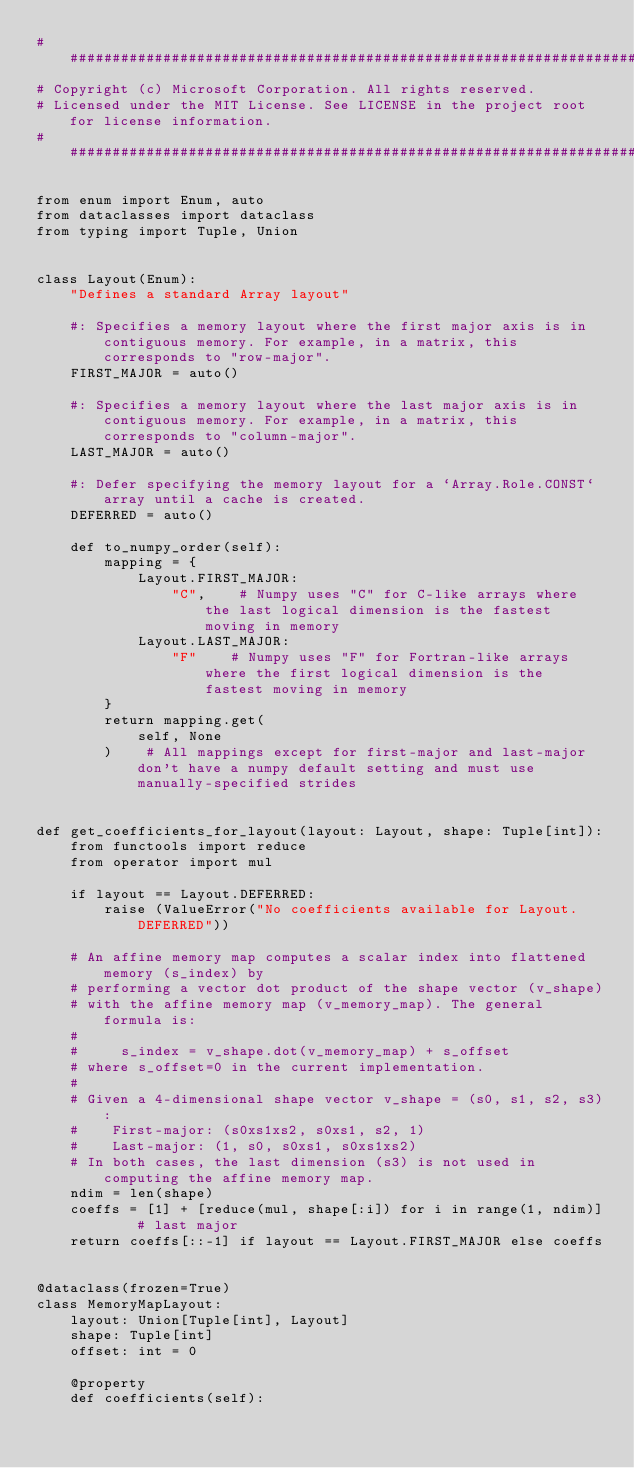Convert code to text. <code><loc_0><loc_0><loc_500><loc_500><_Python_>####################################################################################################
# Copyright (c) Microsoft Corporation. All rights reserved.
# Licensed under the MIT License. See LICENSE in the project root for license information.
####################################################################################################

from enum import Enum, auto
from dataclasses import dataclass
from typing import Tuple, Union


class Layout(Enum):
    "Defines a standard Array layout"

    #: Specifies a memory layout where the first major axis is in contiguous memory. For example, in a matrix, this corresponds to "row-major".
    FIRST_MAJOR = auto()

    #: Specifies a memory layout where the last major axis is in contiguous memory. For example, in a matrix, this corresponds to "column-major".
    LAST_MAJOR = auto()

    #: Defer specifying the memory layout for a `Array.Role.CONST` array until a cache is created.
    DEFERRED = auto()

    def to_numpy_order(self):
        mapping = {
            Layout.FIRST_MAJOR:
                "C",    # Numpy uses "C" for C-like arrays where the last logical dimension is the fastest moving in memory
            Layout.LAST_MAJOR:
                "F"    # Numpy uses "F" for Fortran-like arrays where the first logical dimension is the fastest moving in memory
        }
        return mapping.get(
            self, None
        )    # All mappings except for first-major and last-major don't have a numpy default setting and must use manually-specified strides


def get_coefficients_for_layout(layout: Layout, shape: Tuple[int]):
    from functools import reduce
    from operator import mul

    if layout == Layout.DEFERRED:
        raise (ValueError("No coefficients available for Layout.DEFERRED"))

    # An affine memory map computes a scalar index into flattened memory (s_index) by
    # performing a vector dot product of the shape vector (v_shape)
    # with the affine memory map (v_memory_map). The general formula is:
    #
    #     s_index = v_shape.dot(v_memory_map) + s_offset
    # where s_offset=0 in the current implementation.
    #
    # Given a 4-dimensional shape vector v_shape = (s0, s1, s2, s3):
    #    First-major: (s0xs1xs2, s0xs1, s2, 1)
    #    Last-major: (1, s0, s0xs1, s0xs1xs2)
    # In both cases, the last dimension (s3) is not used in computing the affine memory map.
    ndim = len(shape)
    coeffs = [1] + [reduce(mul, shape[:i]) for i in range(1, ndim)]    # last major
    return coeffs[::-1] if layout == Layout.FIRST_MAJOR else coeffs


@dataclass(frozen=True)
class MemoryMapLayout:
    layout: Union[Tuple[int], Layout]
    shape: Tuple[int]
    offset: int = 0

    @property
    def coefficients(self):</code> 